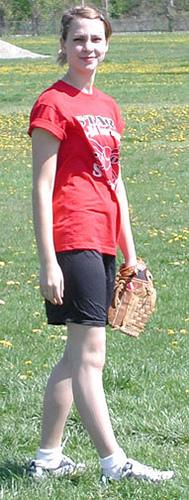Is this woman holding a parasol?
Answer briefly. No. What color shirt is the taller girl wearing?
Concise answer only. Red. What color are her shoes?
Write a very short answer. White. What is in the girls hand?
Keep it brief. Glove. Does the girl wear white socks?
Be succinct. Yes. Does the woman have a tan?
Give a very brief answer. No. Are they playing a game?
Answer briefly. Yes. 